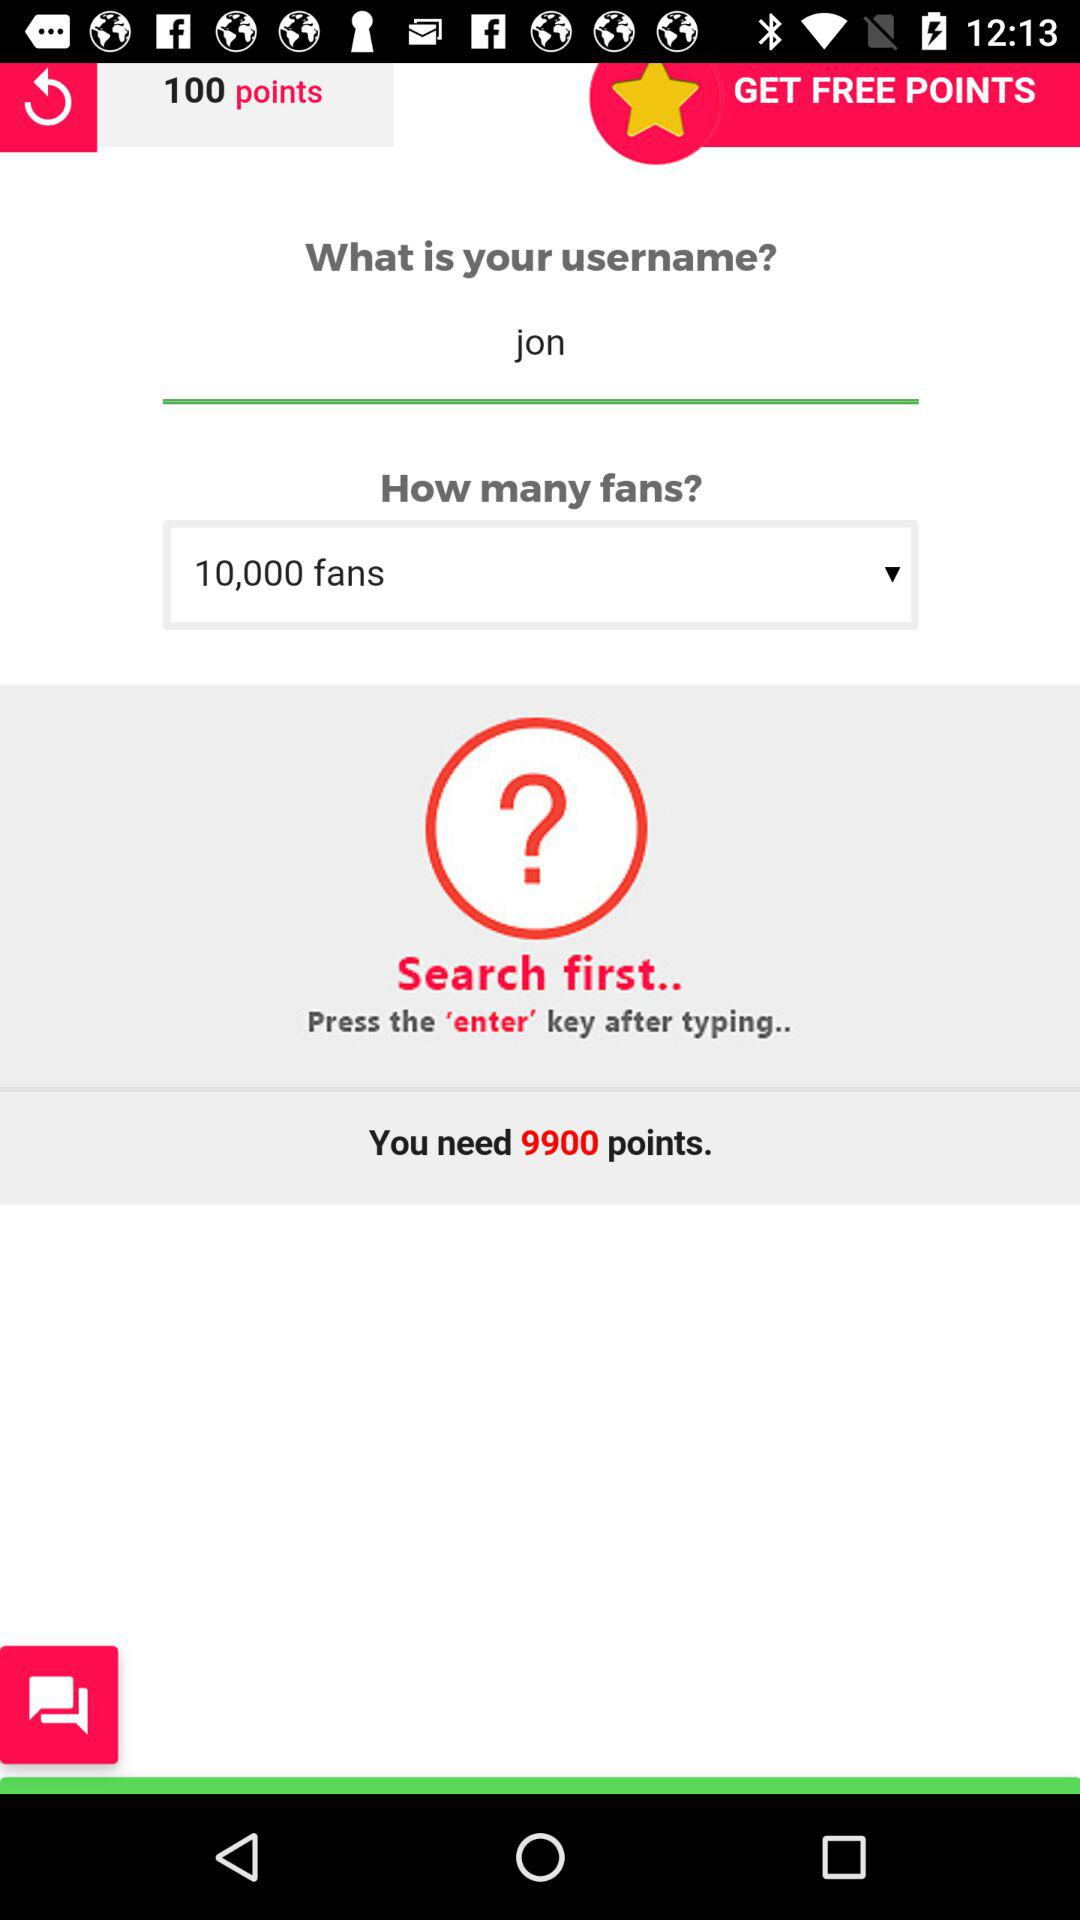Which key has to be pressed after typing? The key that has to be pressed after typing is "enter". 